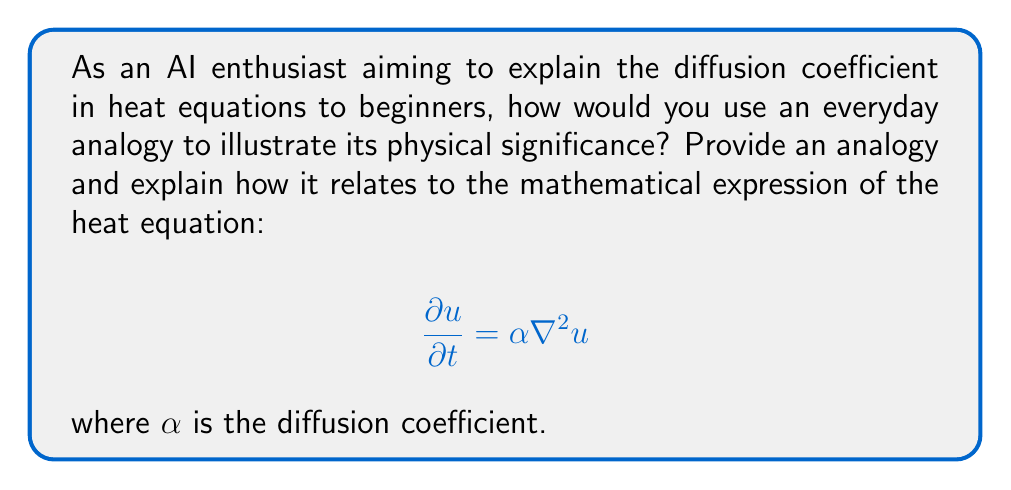Can you answer this question? To explain the physical significance of the diffusion coefficient in heat equations using an everyday analogy, we can follow these steps:

1. Choose an analogy: Let's use the spreading of a drop of food coloring in water as our analogy.

2. Describe the analogy:
   - Imagine dropping a small amount of food coloring into a glass of still water.
   - The food coloring slowly spreads out, eventually coloring the entire glass.

3. Relate the analogy to heat diffusion:
   - The food coloring represents heat in our analogy.
   - The water represents the medium through which heat diffuses.

4. Explain the diffusion coefficient $\alpha$:
   - In our analogy, $\alpha$ would represent how quickly the food coloring spreads.
   - A higher $\alpha$ means the food coloring spreads faster, just as a higher diffusion coefficient in the heat equation means heat spreads more quickly through a material.

5. Connect to the heat equation:
   - In the equation $\frac{\partial u}{\partial t} = \alpha \nabla^2 u$:
     - $u$ represents the temperature (or concentration of food coloring in our analogy)
     - $\frac{\partial u}{\partial t}$ is the rate of change of temperature over time
     - $\nabla^2 u$ represents how the temperature varies in space
     - $\alpha$ determines how quickly these spatial variations in temperature even out over time

6. Illustrate the effect of different $\alpha$ values:
   - A material with high $\alpha$ (like copper) would be like dropping food coloring into very hot water - it spreads quickly.
   - A material with low $\alpha$ (like wood) would be like dropping food coloring into very cold water - it spreads slowly.

7. Emphasize the physical meaning:
   - The diffusion coefficient $\alpha$ essentially measures how easily heat (or in our analogy, food coloring) can flow through a material.
   - It combines several physical properties of the material, including thermal conductivity, density, and specific heat capacity.

By using this analogy, beginners can visualize the abstract concept of the diffusion coefficient and understand its role in determining how quickly heat spreads through a material.
Answer: The diffusion coefficient $\alpha$ in the heat equation represents how quickly heat spreads through a material, analogous to how fast food coloring disperses in water. 